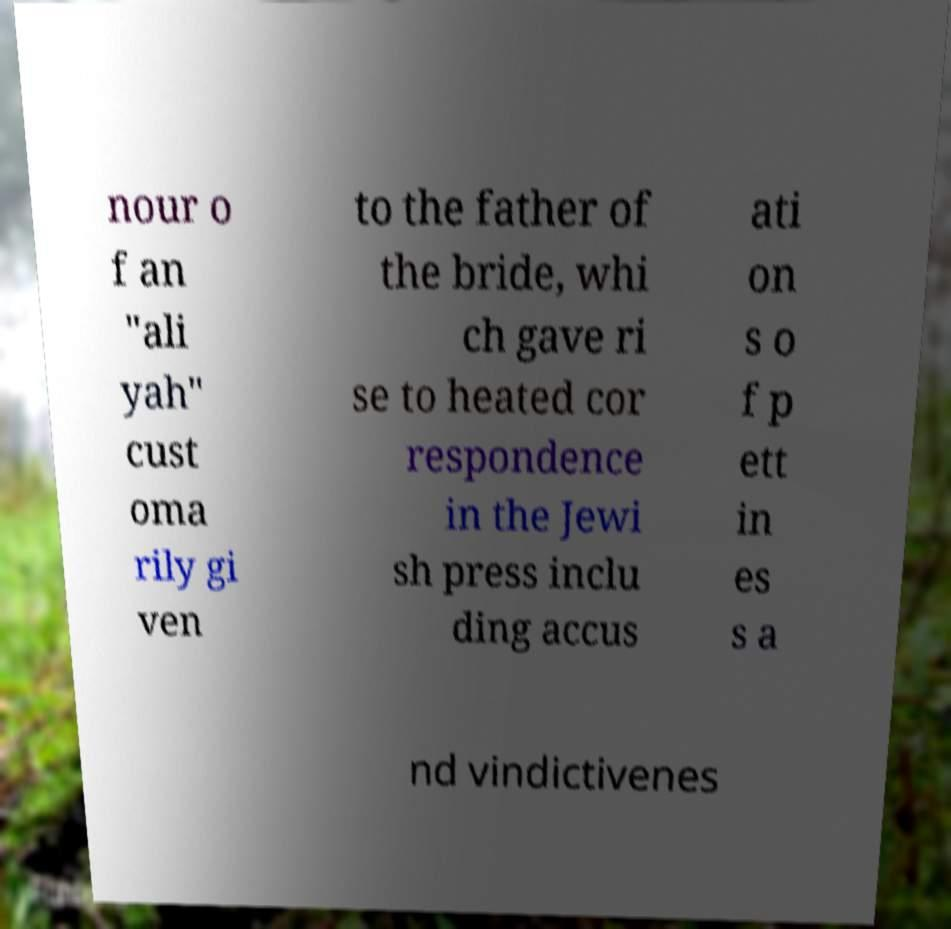Please identify and transcribe the text found in this image. nour o f an "ali yah" cust oma rily gi ven to the father of the bride, whi ch gave ri se to heated cor respondence in the Jewi sh press inclu ding accus ati on s o f p ett in es s a nd vindictivenes 